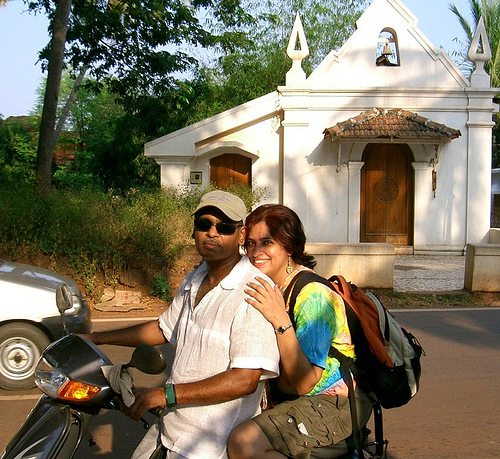What do you imagine they might be talking about? Given their relaxed expressions and casual posture, they might be discussing their itinerary, sharing observations about the places they've visited, or simply enjoying a light-hearted conversation about their surroundings or the pleasant weather. Their content expressions could also hint at them reminiscing about past experiences or making plans for the rest of their day. 